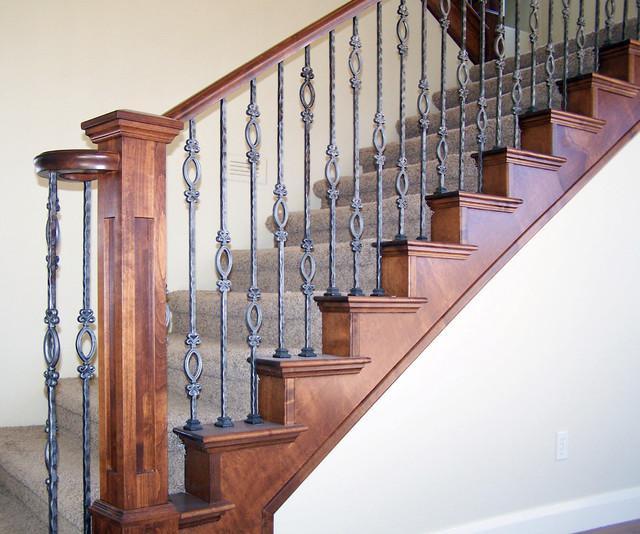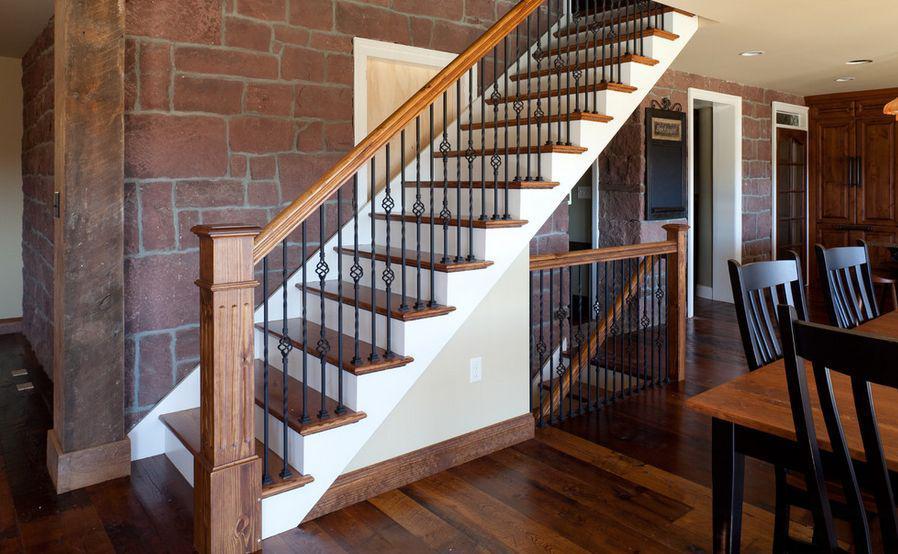The first image is the image on the left, the second image is the image on the right. For the images shown, is this caption "An image shows a staircase that ascends rightward next to an arch doorway, and the staircase has wooden steps with white base boards." true? Answer yes or no. No. The first image is the image on the left, the second image is the image on the right. Assess this claim about the two images: "One set of vertical railings is plain with no design.". Correct or not? Answer yes or no. No. 